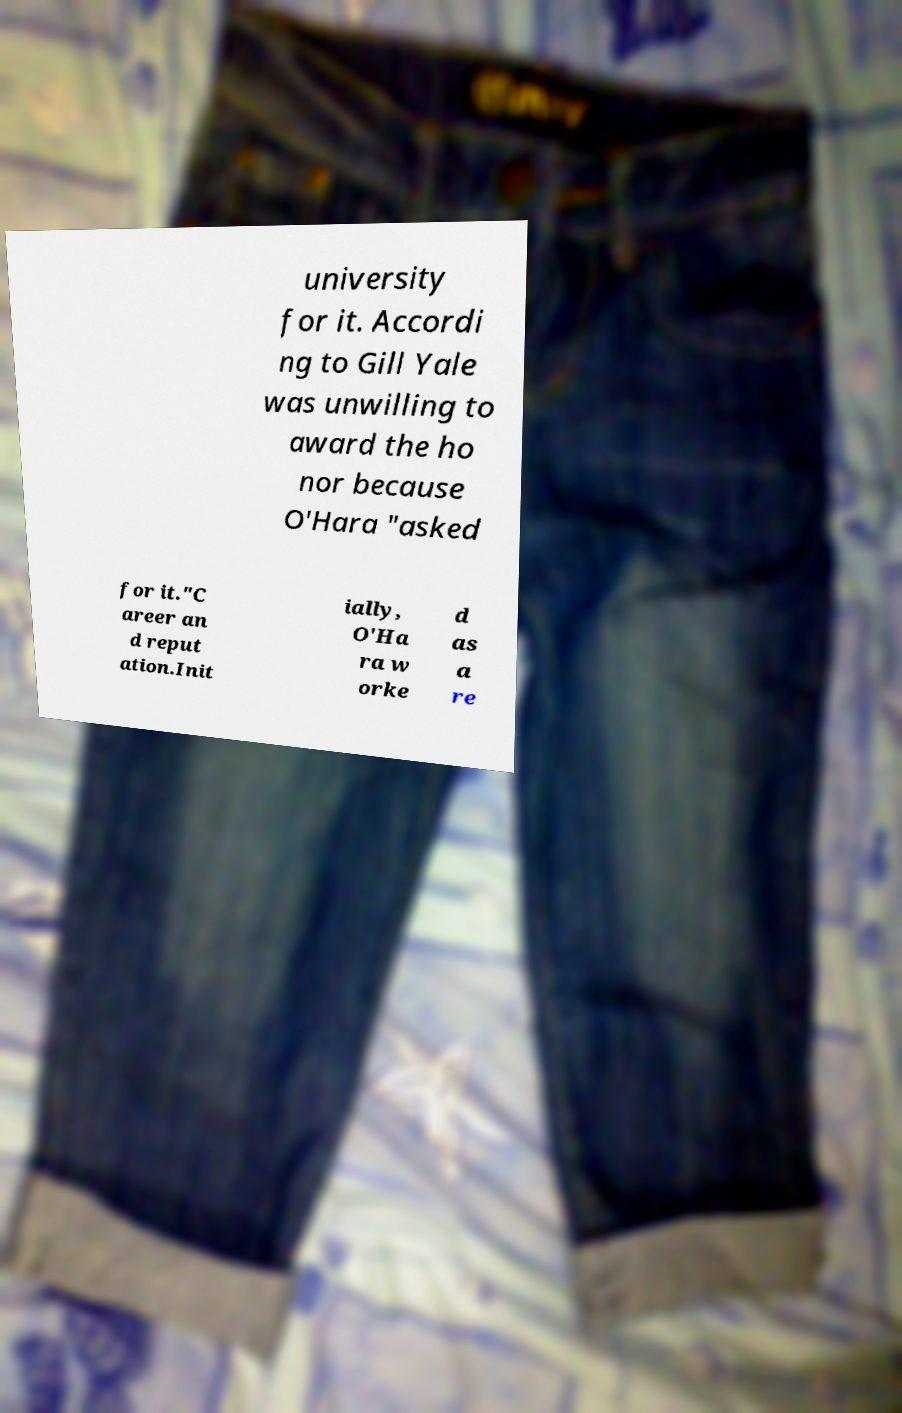Could you assist in decoding the text presented in this image and type it out clearly? university for it. Accordi ng to Gill Yale was unwilling to award the ho nor because O'Hara "asked for it."C areer an d reput ation.Init ially, O'Ha ra w orke d as a re 